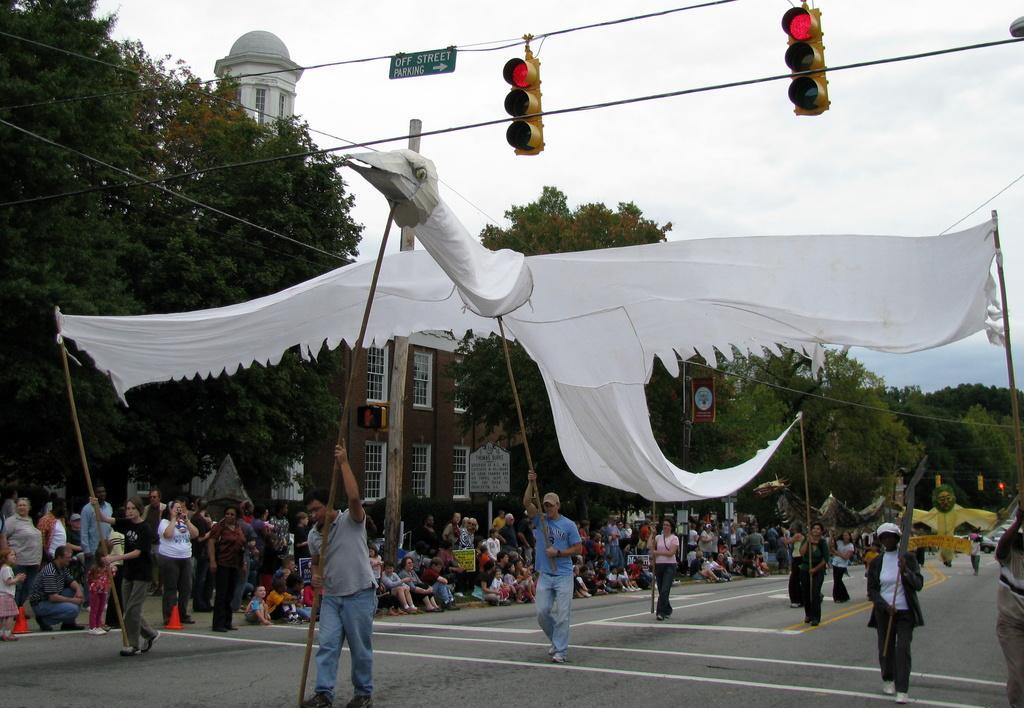Can you describe this image briefly? Here in this picture we can see an eagle made with a cloth being carried by persons with help of poles in their hands, present on the road over there and we can see other people sitting and standing on the road and we can see building present over there and we can see trees and plants present all over there and at the top we can see traffic signal lights present and we can also see street board present over there and we can see clouds in the sky. 